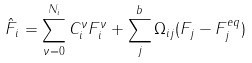Convert formula to latex. <formula><loc_0><loc_0><loc_500><loc_500>\hat { F } _ { i } = \sum ^ { N _ { i } } _ { \nu = 0 } C _ { i } ^ { \nu } F _ { i } ^ { \nu } + \sum _ { j } ^ { b } \Omega _ { i j } ( F _ { j } - F _ { j } ^ { e q } )</formula> 